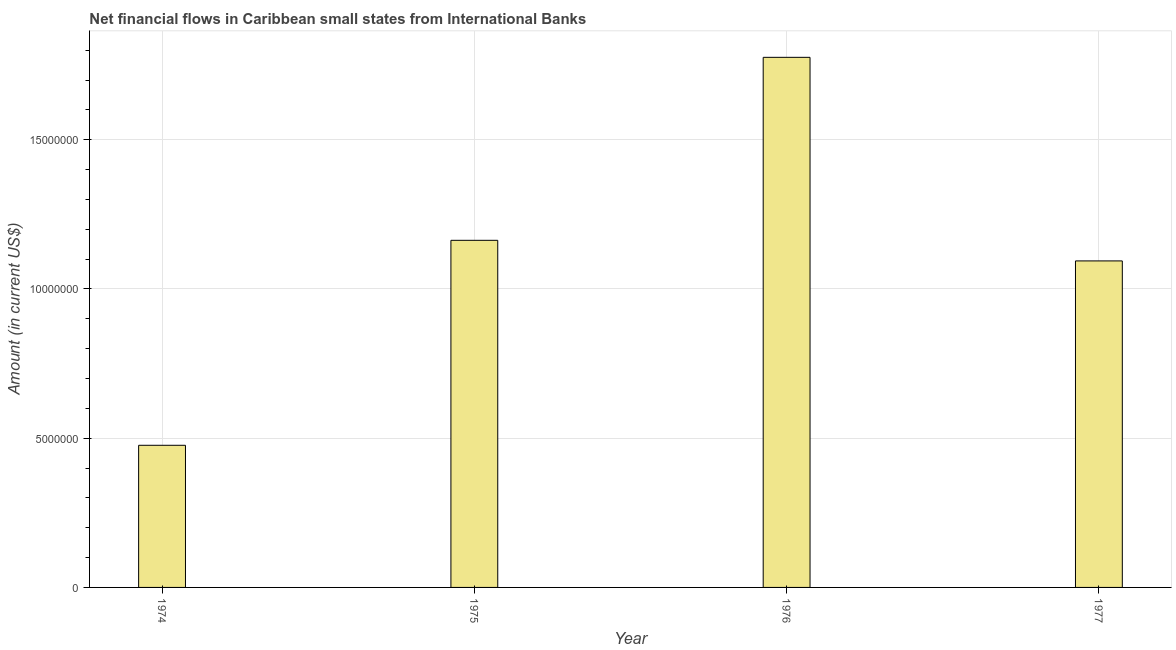What is the title of the graph?
Keep it short and to the point. Net financial flows in Caribbean small states from International Banks. What is the label or title of the X-axis?
Make the answer very short. Year. What is the label or title of the Y-axis?
Your answer should be very brief. Amount (in current US$). What is the net financial flows from ibrd in 1976?
Keep it short and to the point. 1.78e+07. Across all years, what is the maximum net financial flows from ibrd?
Offer a very short reply. 1.78e+07. Across all years, what is the minimum net financial flows from ibrd?
Provide a short and direct response. 4.76e+06. In which year was the net financial flows from ibrd maximum?
Give a very brief answer. 1976. In which year was the net financial flows from ibrd minimum?
Provide a succinct answer. 1974. What is the sum of the net financial flows from ibrd?
Your response must be concise. 4.51e+07. What is the difference between the net financial flows from ibrd in 1976 and 1977?
Make the answer very short. 6.82e+06. What is the average net financial flows from ibrd per year?
Offer a very short reply. 1.13e+07. What is the median net financial flows from ibrd?
Offer a terse response. 1.13e+07. In how many years, is the net financial flows from ibrd greater than 3000000 US$?
Your response must be concise. 4. What is the ratio of the net financial flows from ibrd in 1974 to that in 1976?
Your answer should be compact. 0.27. Is the difference between the net financial flows from ibrd in 1974 and 1976 greater than the difference between any two years?
Offer a terse response. Yes. What is the difference between the highest and the second highest net financial flows from ibrd?
Offer a terse response. 6.13e+06. What is the difference between the highest and the lowest net financial flows from ibrd?
Your answer should be compact. 1.30e+07. In how many years, is the net financial flows from ibrd greater than the average net financial flows from ibrd taken over all years?
Provide a short and direct response. 2. What is the difference between two consecutive major ticks on the Y-axis?
Provide a short and direct response. 5.00e+06. What is the Amount (in current US$) of 1974?
Your answer should be very brief. 4.76e+06. What is the Amount (in current US$) in 1975?
Offer a terse response. 1.16e+07. What is the Amount (in current US$) of 1976?
Provide a short and direct response. 1.78e+07. What is the Amount (in current US$) in 1977?
Provide a succinct answer. 1.09e+07. What is the difference between the Amount (in current US$) in 1974 and 1975?
Your response must be concise. -6.87e+06. What is the difference between the Amount (in current US$) in 1974 and 1976?
Your answer should be very brief. -1.30e+07. What is the difference between the Amount (in current US$) in 1974 and 1977?
Your answer should be very brief. -6.18e+06. What is the difference between the Amount (in current US$) in 1975 and 1976?
Give a very brief answer. -6.13e+06. What is the difference between the Amount (in current US$) in 1975 and 1977?
Provide a short and direct response. 6.90e+05. What is the difference between the Amount (in current US$) in 1976 and 1977?
Your answer should be very brief. 6.82e+06. What is the ratio of the Amount (in current US$) in 1974 to that in 1975?
Make the answer very short. 0.41. What is the ratio of the Amount (in current US$) in 1974 to that in 1976?
Your answer should be compact. 0.27. What is the ratio of the Amount (in current US$) in 1974 to that in 1977?
Make the answer very short. 0.43. What is the ratio of the Amount (in current US$) in 1975 to that in 1976?
Offer a terse response. 0.66. What is the ratio of the Amount (in current US$) in 1975 to that in 1977?
Give a very brief answer. 1.06. What is the ratio of the Amount (in current US$) in 1976 to that in 1977?
Your answer should be very brief. 1.62. 